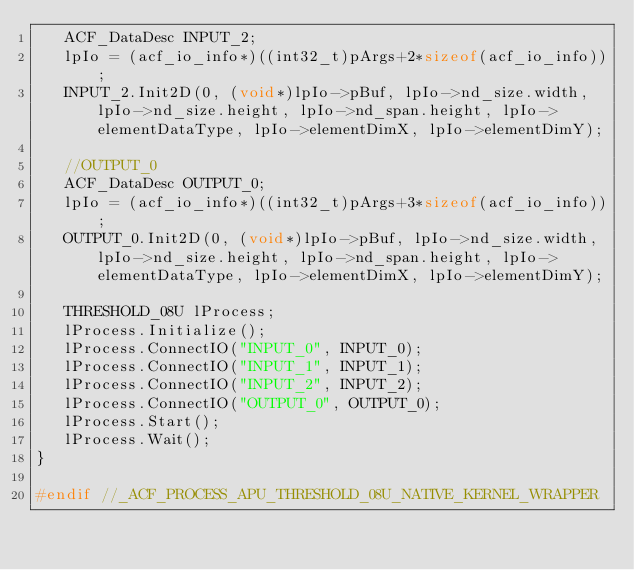Convert code to text. <code><loc_0><loc_0><loc_500><loc_500><_C++_>   ACF_DataDesc INPUT_2;
   lpIo = (acf_io_info*)((int32_t)pArgs+2*sizeof(acf_io_info));
   INPUT_2.Init2D(0, (void*)lpIo->pBuf, lpIo->nd_size.width, lpIo->nd_size.height, lpIo->nd_span.height, lpIo->elementDataType, lpIo->elementDimX, lpIo->elementDimY);

   //OUTPUT_0
   ACF_DataDesc OUTPUT_0;
   lpIo = (acf_io_info*)((int32_t)pArgs+3*sizeof(acf_io_info));
   OUTPUT_0.Init2D(0, (void*)lpIo->pBuf, lpIo->nd_size.width, lpIo->nd_size.height, lpIo->nd_span.height, lpIo->elementDataType, lpIo->elementDimX, lpIo->elementDimY);

   THRESHOLD_08U lProcess;
   lProcess.Initialize();
   lProcess.ConnectIO("INPUT_0", INPUT_0);
   lProcess.ConnectIO("INPUT_1", INPUT_1);
   lProcess.ConnectIO("INPUT_2", INPUT_2);
   lProcess.ConnectIO("OUTPUT_0", OUTPUT_0);
   lProcess.Start();
   lProcess.Wait();
}

#endif //_ACF_PROCESS_APU_THRESHOLD_08U_NATIVE_KERNEL_WRAPPER
</code> 